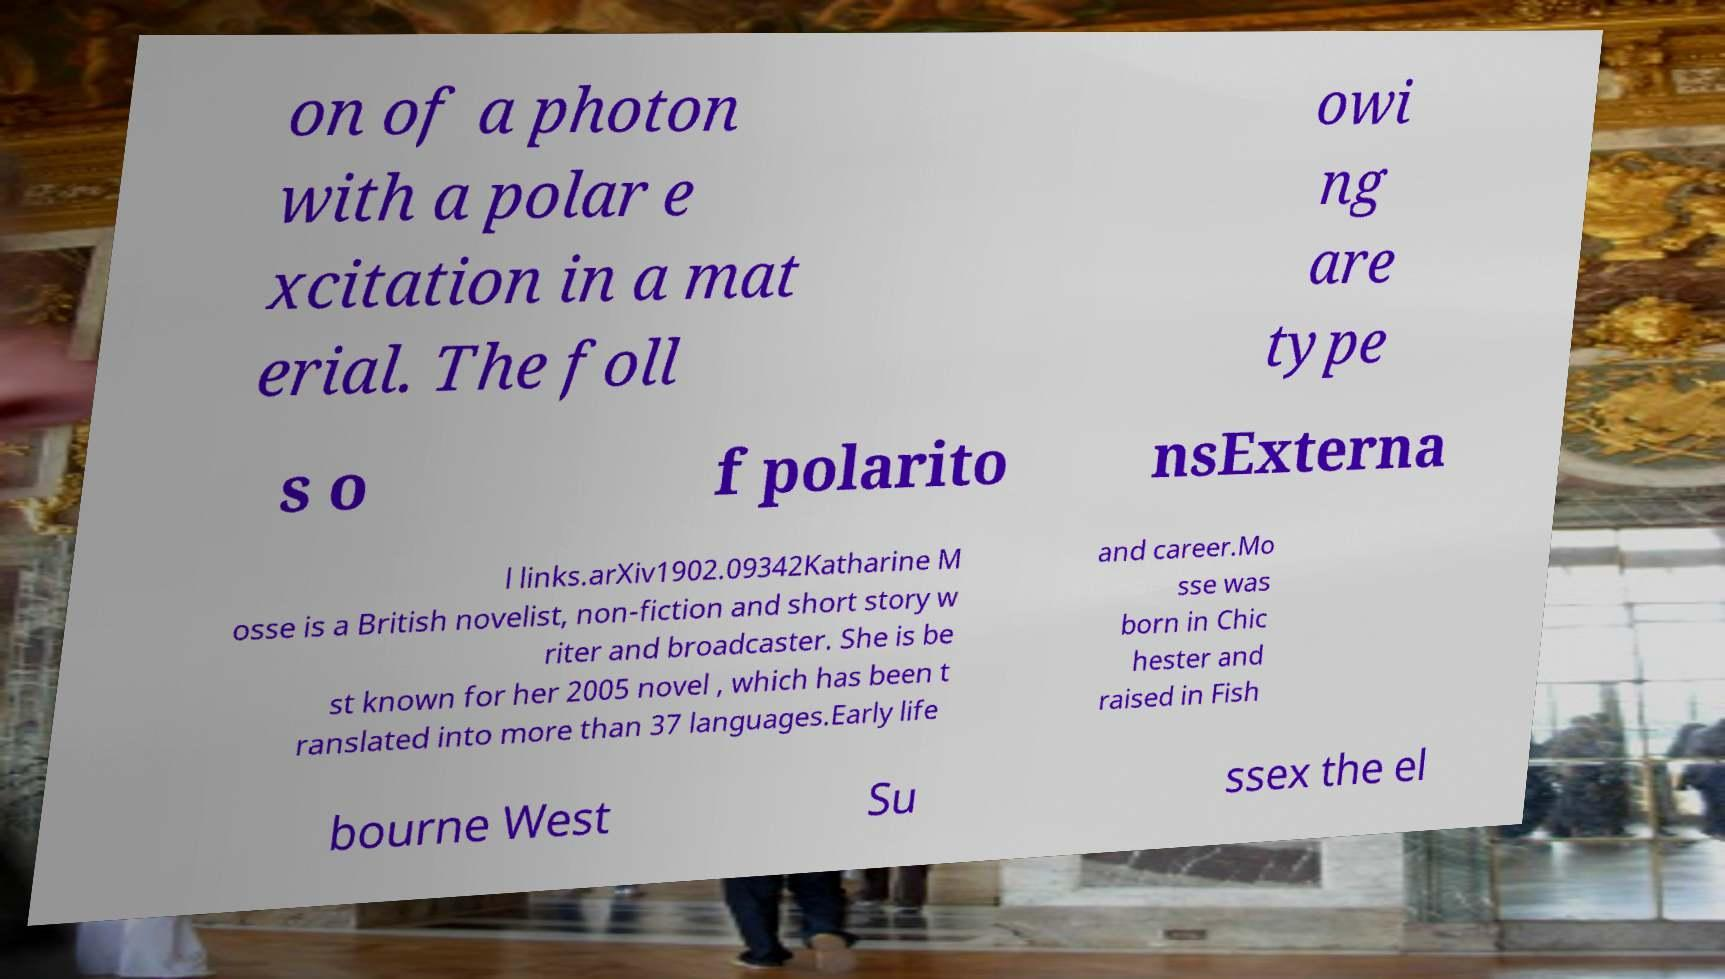Please identify and transcribe the text found in this image. on of a photon with a polar e xcitation in a mat erial. The foll owi ng are type s o f polarito nsExterna l links.arXiv1902.09342Katharine M osse is a British novelist, non-fiction and short story w riter and broadcaster. She is be st known for her 2005 novel , which has been t ranslated into more than 37 languages.Early life and career.Mo sse was born in Chic hester and raised in Fish bourne West Su ssex the el 